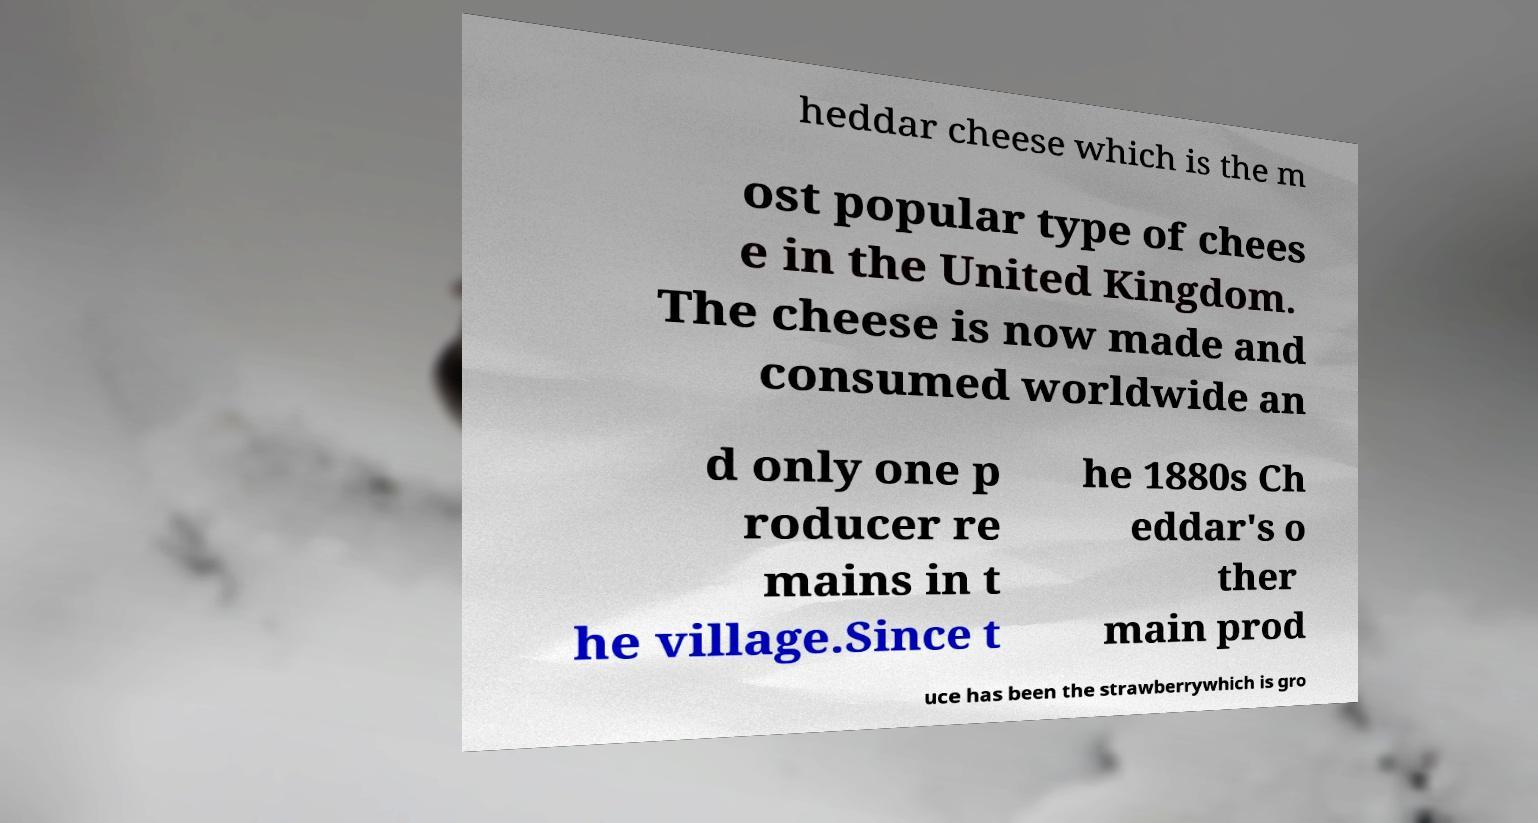Please read and relay the text visible in this image. What does it say? heddar cheese which is the m ost popular type of chees e in the United Kingdom. The cheese is now made and consumed worldwide an d only one p roducer re mains in t he village.Since t he 1880s Ch eddar's o ther main prod uce has been the strawberrywhich is gro 